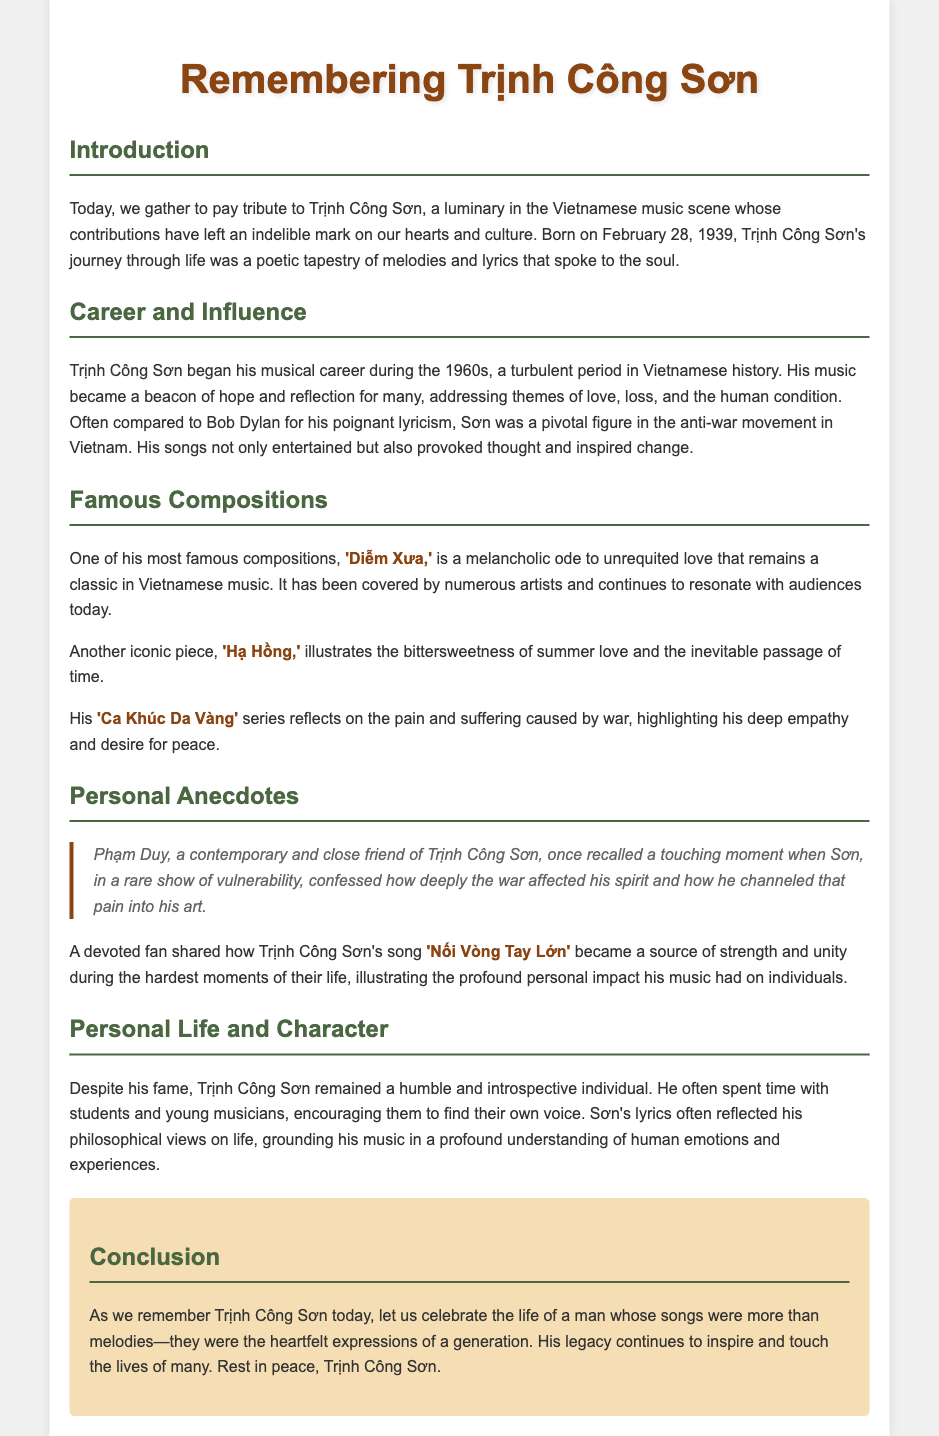what is the birth date of Trịnh Công Sơn? The document states that Trịnh Công Sơn was born on February 28, 1939.
Answer: February 28, 1939 which song is described as a melancholic ode to unrequited love? The document specifies that the song 'Diễm Xưa' is a melancholic ode to unrequited love.
Answer: 'Diễm Xưa' who compared Trịnh Công Sơn's lyricism to Bob Dylan? The document does not explicitly state who made the comparison, but it mentions that he is often compared to Bob Dylan.
Answer: Unknown what theme is prevalent in Trịnh Công Sơn's music according to the document? The document discusses themes of love, loss, and the human condition as prevalent in his music.
Answer: Love, loss, and the human condition what does 'Nối Vòng Tay Lớn' represent for a devoted fan? According to the document, 'Nối Vòng Tay Lớn' became a source of strength and unity for a devoted fan.
Answer: Strength and unity what did Trịnh Công Sơn do despite his fame? The document mentions that he spent time with students and young musicians, encouraging them.
Answer: Encouraged young musicians which series reflects Trịnh Công Sơn's views on war? The document refers to his 'Ca Khúc Da Vàng' series as reflecting on the pain and suffering caused by war.
Answer: 'Ca Khúc Da Vàng' what does the document call Trịnh Công Sơn in the introduction? The introduction refers to him as a luminary in the Vietnamese music scene.
Answer: Luminary 